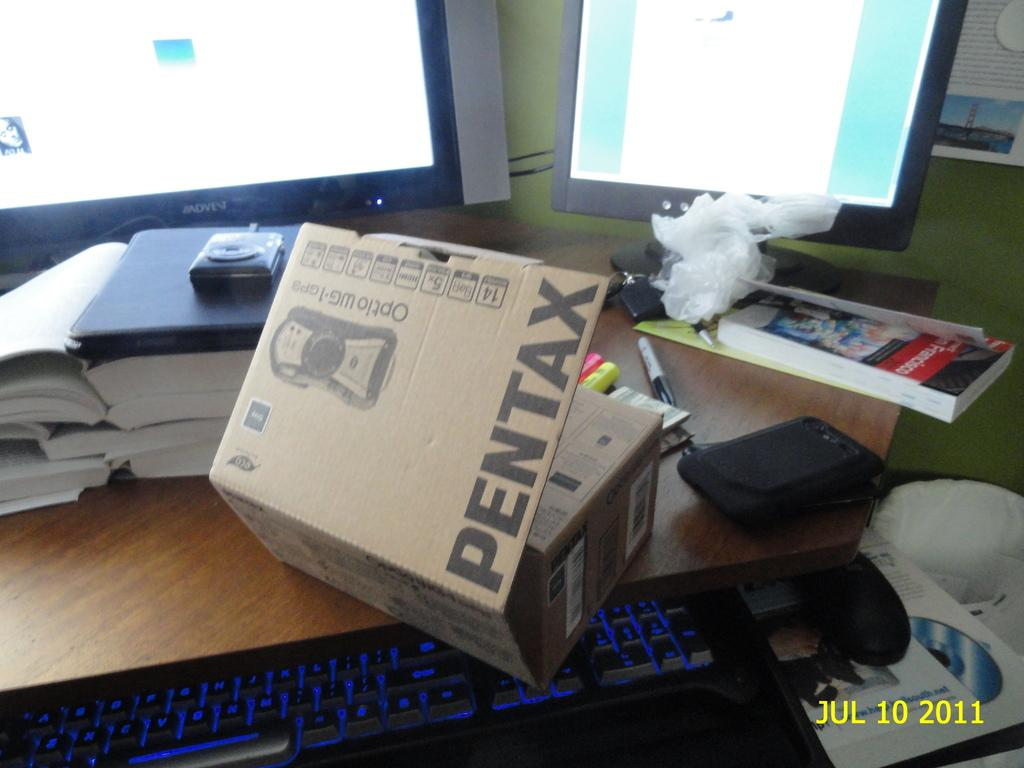<image>
Offer a succinct explanation of the picture presented. A Pentax Camera Box lies open on a desk with two computer screens behind it. 